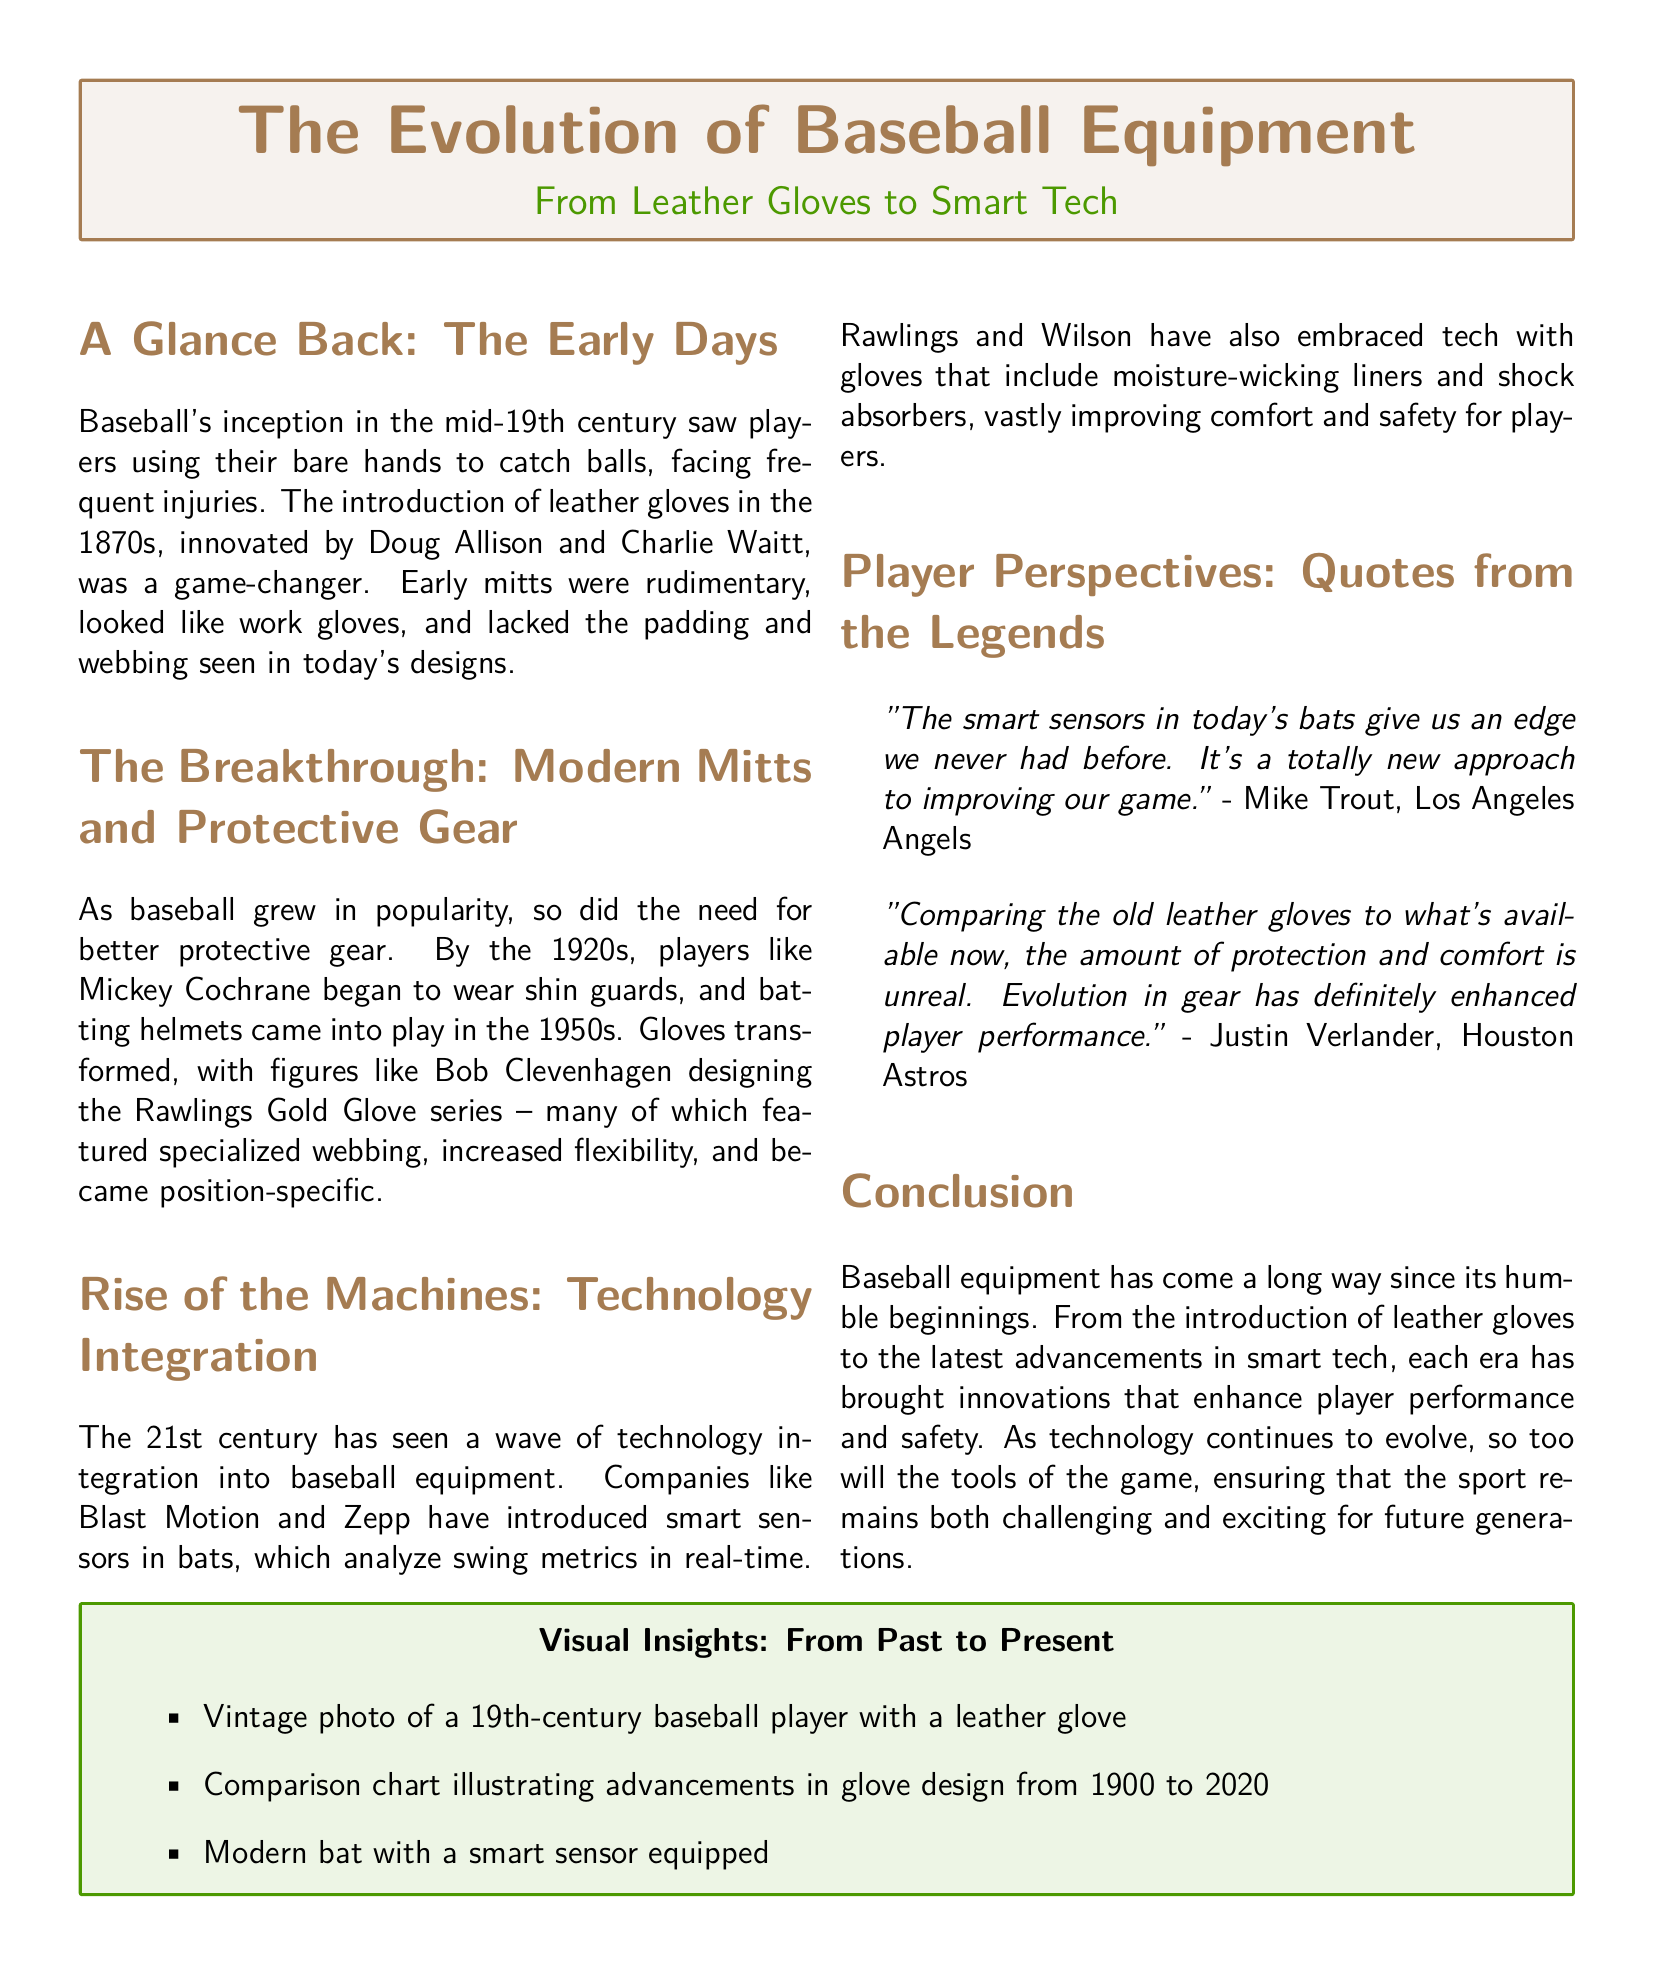What decade saw the introduction of leather gloves in baseball? The document states that leather gloves were introduced in the 1870s, which is the decade in question.
Answer: 1870s Who innovated the early leather gloves? The early leather gloves were innovated by Doug Allison and Charlie Waitt, as mentioned in the document.
Answer: Doug Allison and Charlie Waitt What protective gear was introduced in the 1920s? The document notes that players like Mickey Cochrane began wearing shin guards in the 1920s, making it the protective equipment of that era.
Answer: Shin guards Which company introduced smart sensors in bats? The document mentions that companies like Blast Motion and Zepp introduced smart sensors in bats, identifying them as key players in this innovation.
Answer: Blast Motion and Zepp What is one major advancement in glove design mentioned in the document? The document highlights that gloves have become position-specific and features specialized webbing, reflecting a significant advancement in design.
Answer: Position-specific and specialized webbing What quote reflects the impact of smart sensors on today's game? The document cites Mike Trout, who discusses how smart sensors in bats give players an edge, indicating their impact on the game.
Answer: "The smart sensors in today's bats give us an edge we never had before." Which era saw the adoption of batting helmets? According to the document, batting helmets came into play in the 1950s, marking the era of this innovation.
Answer: 1950s Name one company that has embraced technology in gloves. The document states that Rawlings is a company that has embraced technology with improved glove features, identifying them as an example.
Answer: Rawlings 